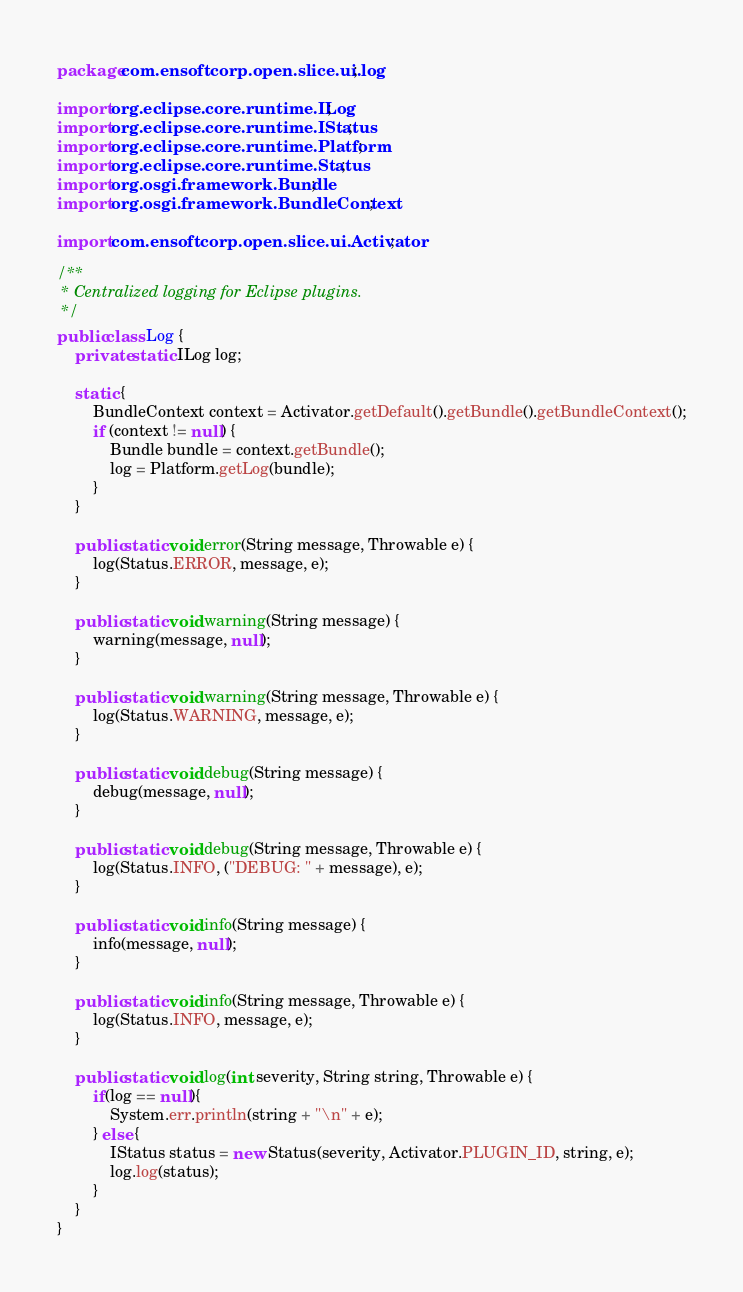Convert code to text. <code><loc_0><loc_0><loc_500><loc_500><_Java_>package com.ensoftcorp.open.slice.ui.log;

import org.eclipse.core.runtime.ILog;
import org.eclipse.core.runtime.IStatus;
import org.eclipse.core.runtime.Platform;
import org.eclipse.core.runtime.Status;
import org.osgi.framework.Bundle;
import org.osgi.framework.BundleContext;

import com.ensoftcorp.open.slice.ui.Activator;

/**
 * Centralized logging for Eclipse plugins.
 */
public class Log {
	private static ILog log;
	
	static {
		BundleContext context = Activator.getDefault().getBundle().getBundleContext();
		if (context != null) {
			Bundle bundle = context.getBundle();
			log = Platform.getLog(bundle);
		}
	}
	
	public static void error(String message, Throwable e) {
		log(Status.ERROR, message, e);
	}
	
	public static void warning(String message) {
		warning(message, null);
	}
	
	public static void warning(String message, Throwable e) {
		log(Status.WARNING, message, e);
	}
	
	public static void debug(String message) {
		debug(message, null);
	}
	
	public static void debug(String message, Throwable e) {
		log(Status.INFO, ("DEBUG: " + message), e);
	}
	
	public static void info(String message) {
		info(message, null);
	}
	
	public static void info(String message, Throwable e) {
		log(Status.INFO, message, e);
	}
	
	public static void log(int severity, String string, Throwable e) {
		if(log == null){
			System.err.println(string + "\n" + e);
		} else {
			IStatus status = new Status(severity, Activator.PLUGIN_ID, string, e);
			log.log(status);
		}
	}
}
</code> 